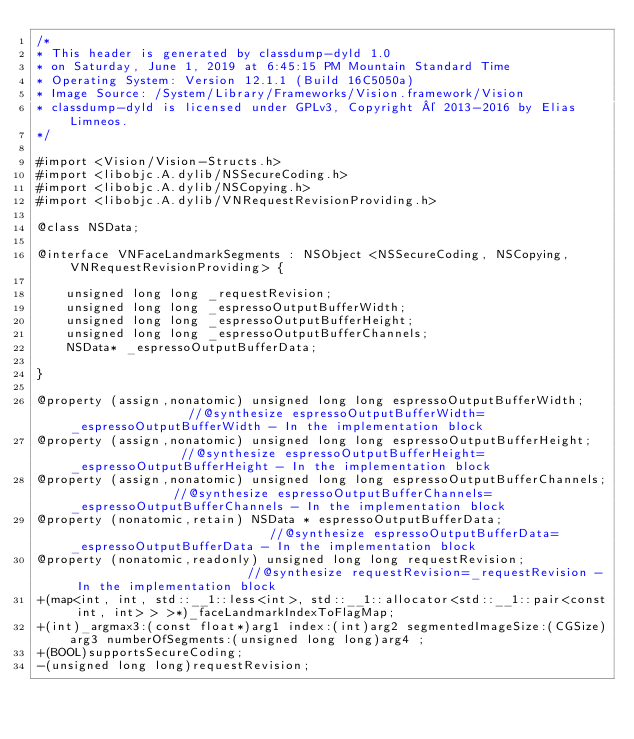<code> <loc_0><loc_0><loc_500><loc_500><_C_>/*
* This header is generated by classdump-dyld 1.0
* on Saturday, June 1, 2019 at 6:45:15 PM Mountain Standard Time
* Operating System: Version 12.1.1 (Build 16C5050a)
* Image Source: /System/Library/Frameworks/Vision.framework/Vision
* classdump-dyld is licensed under GPLv3, Copyright © 2013-2016 by Elias Limneos.
*/

#import <Vision/Vision-Structs.h>
#import <libobjc.A.dylib/NSSecureCoding.h>
#import <libobjc.A.dylib/NSCopying.h>
#import <libobjc.A.dylib/VNRequestRevisionProviding.h>

@class NSData;

@interface VNFaceLandmarkSegments : NSObject <NSSecureCoding, NSCopying, VNRequestRevisionProviding> {

	unsigned long long _requestRevision;
	unsigned long long _espressoOutputBufferWidth;
	unsigned long long _espressoOutputBufferHeight;
	unsigned long long _espressoOutputBufferChannels;
	NSData* _espressoOutputBufferData;

}

@property (assign,nonatomic) unsigned long long espressoOutputBufferWidth;                 //@synthesize espressoOutputBufferWidth=_espressoOutputBufferWidth - In the implementation block
@property (assign,nonatomic) unsigned long long espressoOutputBufferHeight;                //@synthesize espressoOutputBufferHeight=_espressoOutputBufferHeight - In the implementation block
@property (assign,nonatomic) unsigned long long espressoOutputBufferChannels;              //@synthesize espressoOutputBufferChannels=_espressoOutputBufferChannels - In the implementation block
@property (nonatomic,retain) NSData * espressoOutputBufferData;                            //@synthesize espressoOutputBufferData=_espressoOutputBufferData - In the implementation block
@property (nonatomic,readonly) unsigned long long requestRevision;                         //@synthesize requestRevision=_requestRevision - In the implementation block
+(map<int, int, std::__1::less<int>, std::__1::allocator<std::__1::pair<const int, int> > >*)_faceLandmarkIndexToFlagMap;
+(int)_argmax3:(const float*)arg1 index:(int)arg2 segmentedImageSize:(CGSize)arg3 numberOfSegments:(unsigned long long)arg4 ;
+(BOOL)supportsSecureCoding;
-(unsigned long long)requestRevision;</code> 